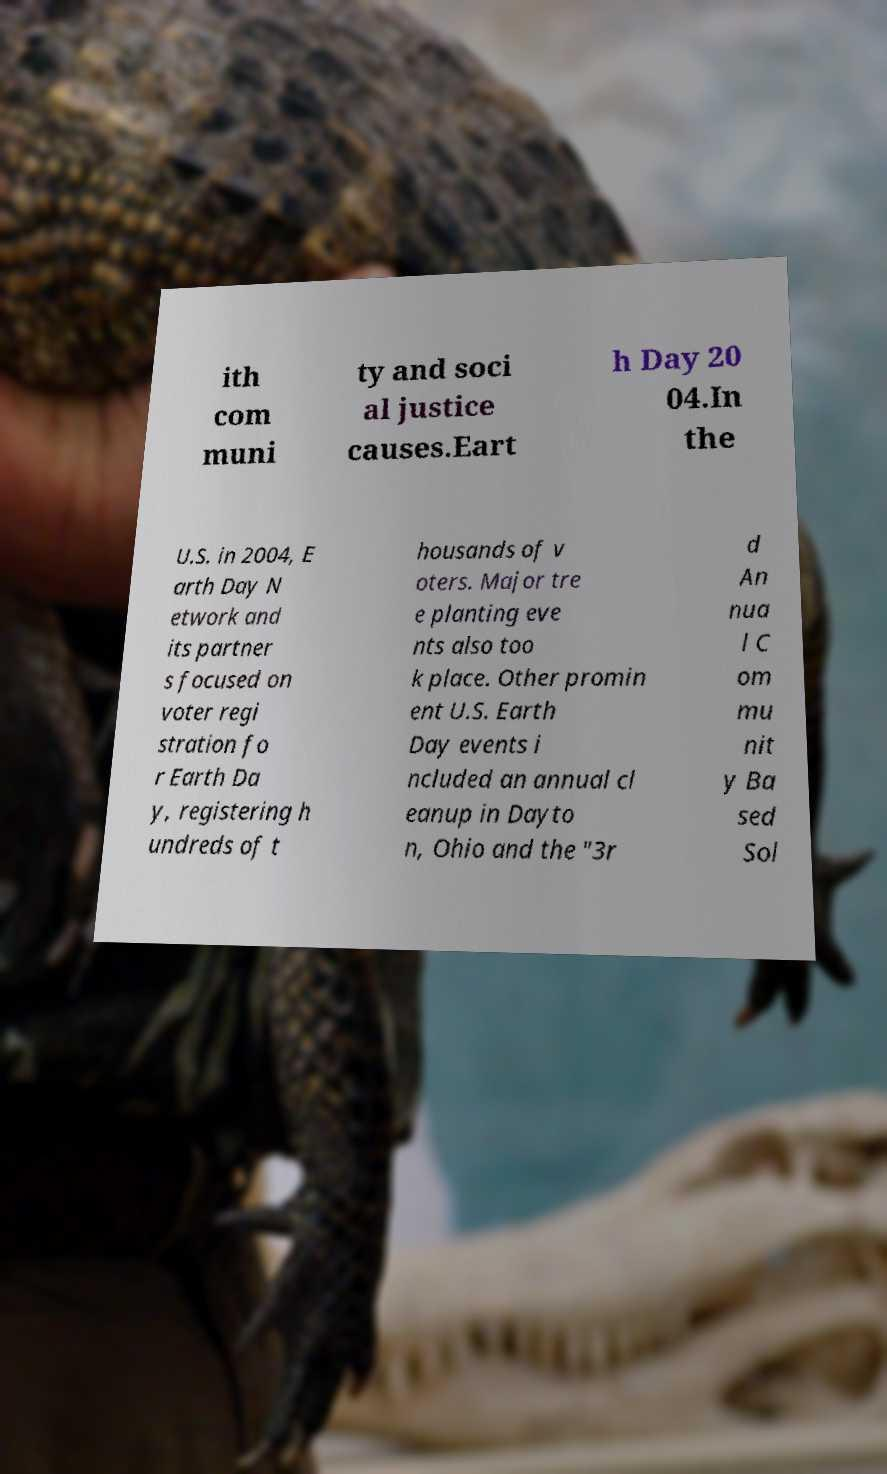Can you read and provide the text displayed in the image?This photo seems to have some interesting text. Can you extract and type it out for me? ith com muni ty and soci al justice causes.Eart h Day 20 04.In the U.S. in 2004, E arth Day N etwork and its partner s focused on voter regi stration fo r Earth Da y, registering h undreds of t housands of v oters. Major tre e planting eve nts also too k place. Other promin ent U.S. Earth Day events i ncluded an annual cl eanup in Dayto n, Ohio and the "3r d An nua l C om mu nit y Ba sed Sol 